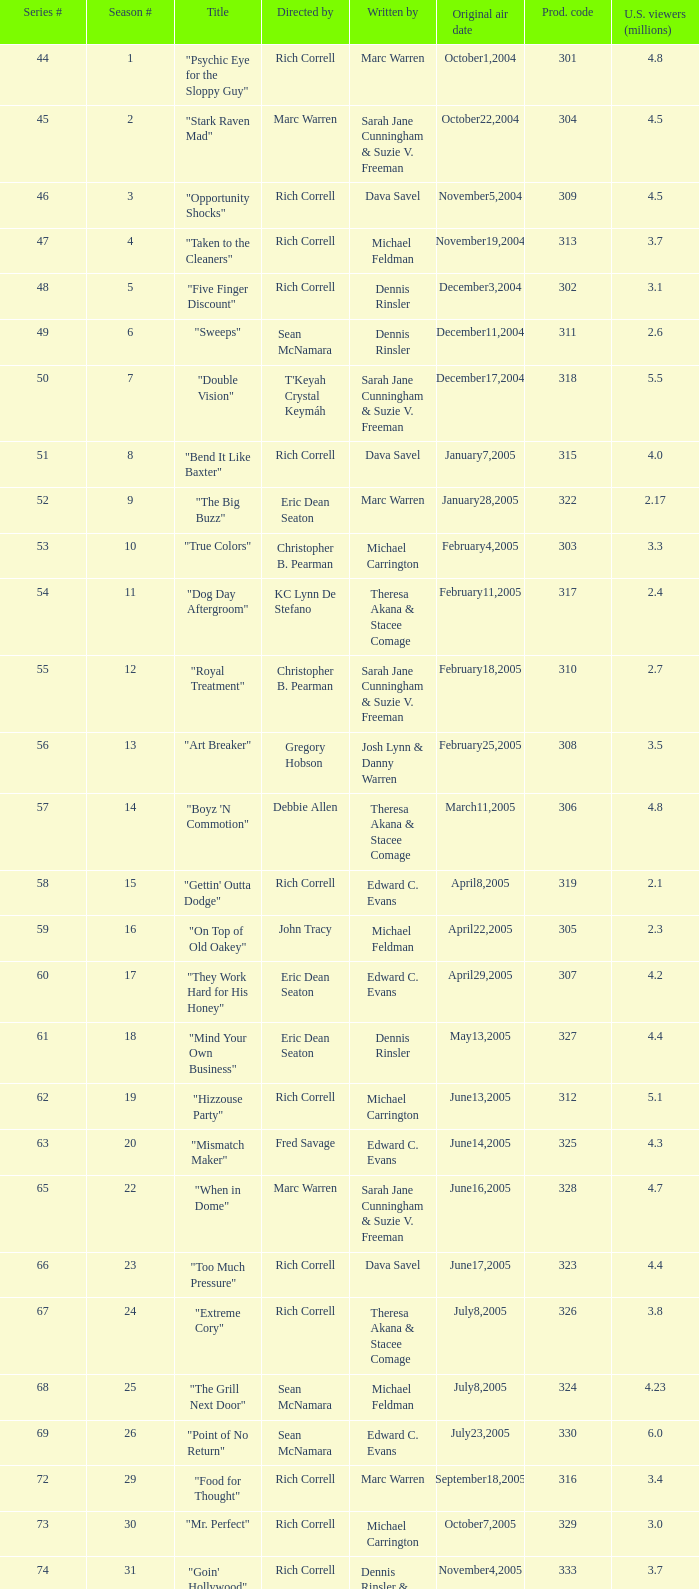What was the production code for the episode helmed by rondell sheridan? 332.0. 